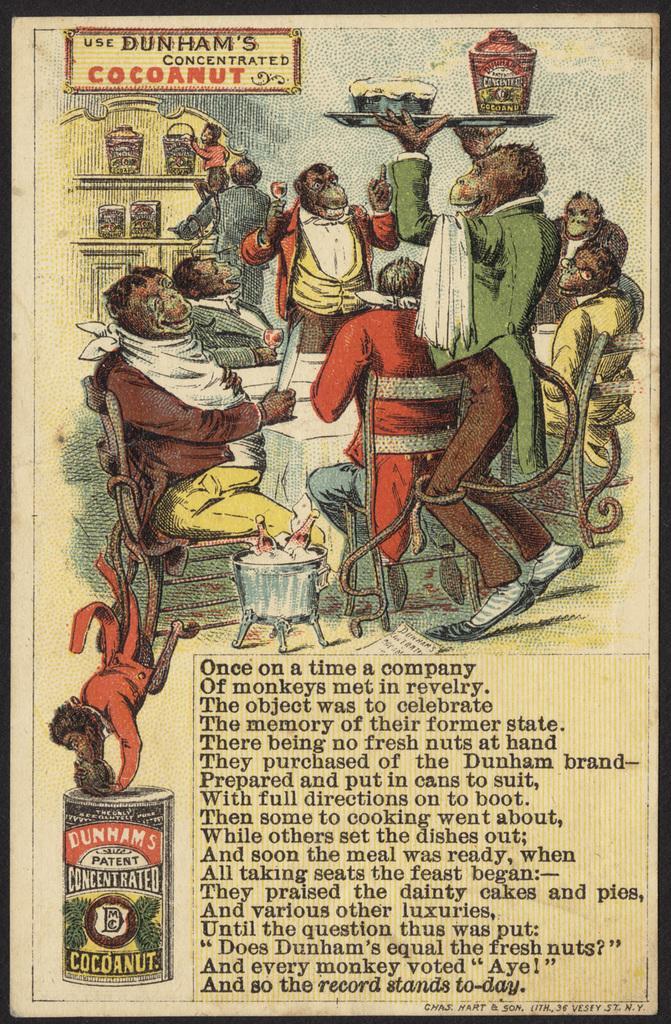In one or two sentences, can you explain what this image depicts? In the picture I can see a group of monkeys wearing dresses are sitting and the remaining are standing and there is a table in front of them which has few objects placed on it and there is something written above and below it. 